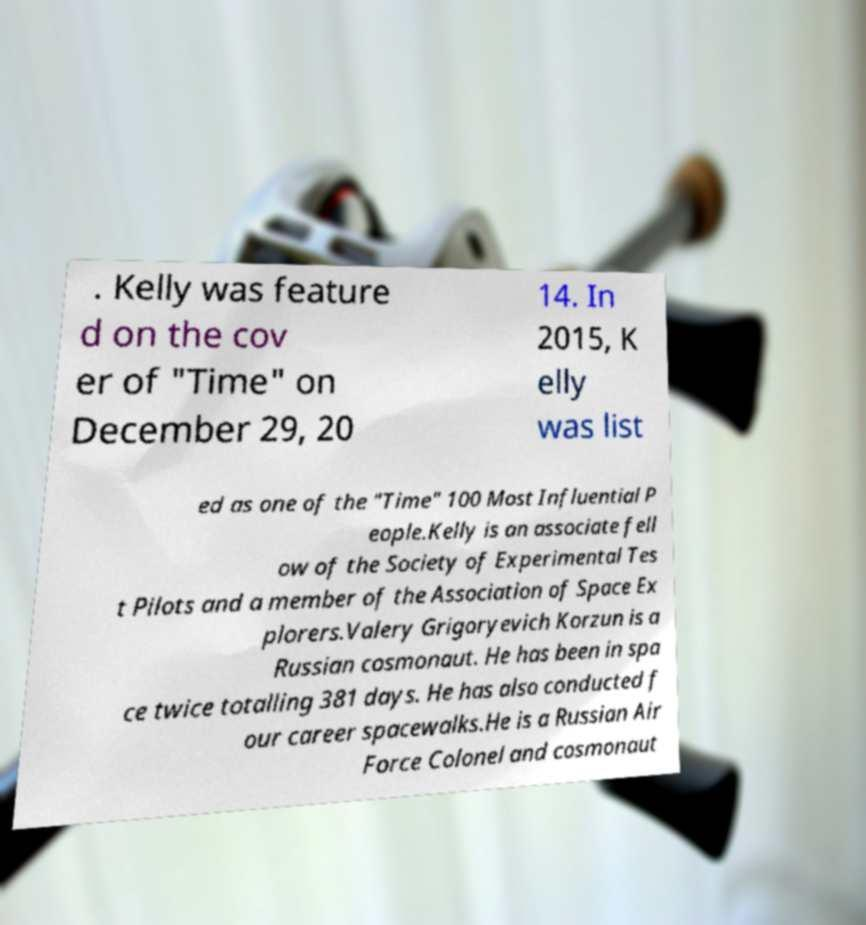What messages or text are displayed in this image? I need them in a readable, typed format. . Kelly was feature d on the cov er of "Time" on December 29, 20 14. In 2015, K elly was list ed as one of the "Time" 100 Most Influential P eople.Kelly is an associate fell ow of the Society of Experimental Tes t Pilots and a member of the Association of Space Ex plorers.Valery Grigoryevich Korzun is a Russian cosmonaut. He has been in spa ce twice totalling 381 days. He has also conducted f our career spacewalks.He is a Russian Air Force Colonel and cosmonaut 